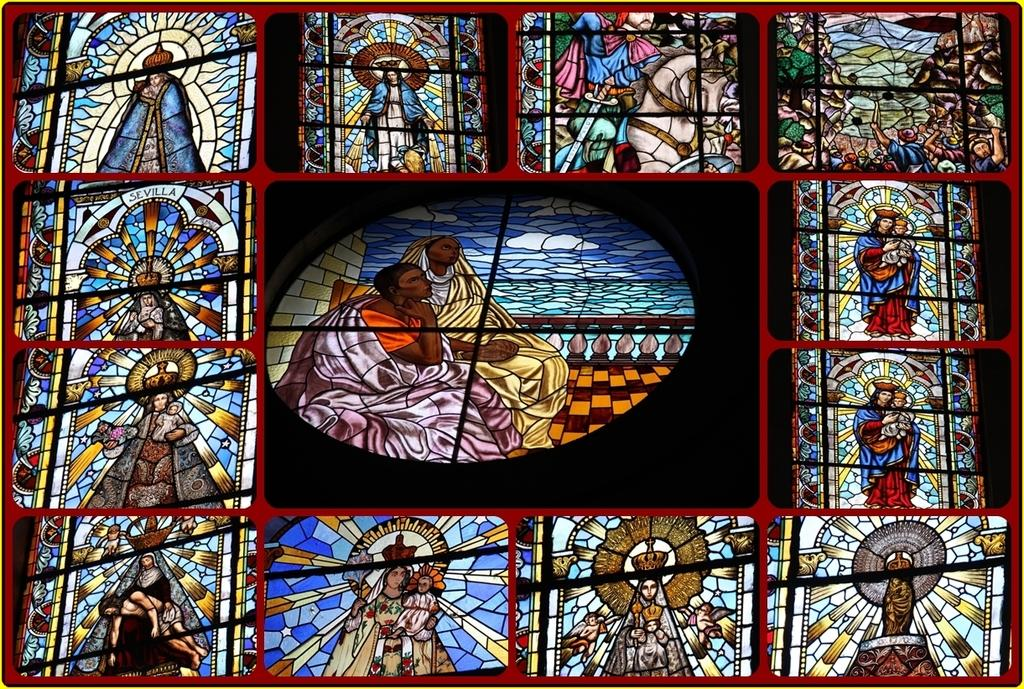What type of art is depicted in the image? There is Christian art in the image. How is the Christian art displayed in the image? The Christian art is on a glass. What type of mist can be seen surrounding the Christian art in the image? There is no mist present in the image; the Christian art is on a glass. 